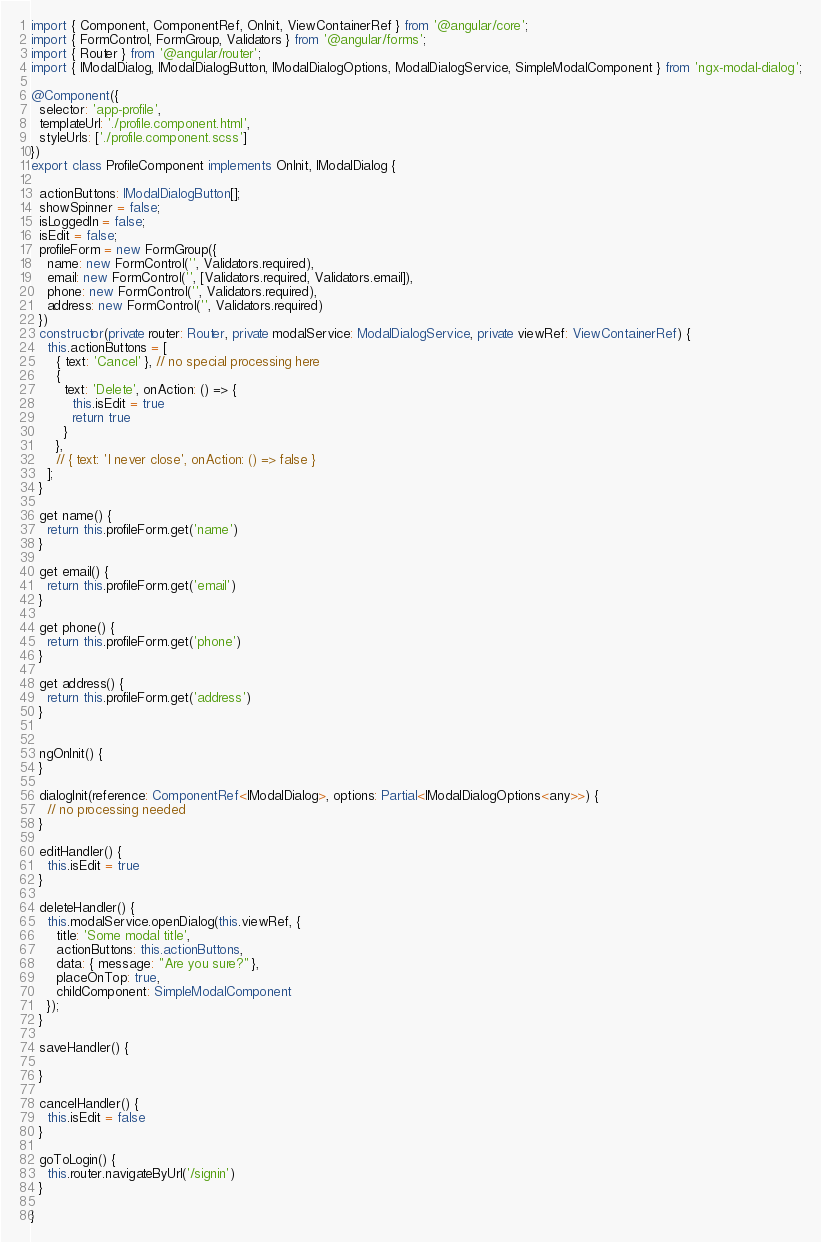Convert code to text. <code><loc_0><loc_0><loc_500><loc_500><_TypeScript_>import { Component, ComponentRef, OnInit, ViewContainerRef } from '@angular/core';
import { FormControl, FormGroup, Validators } from '@angular/forms';
import { Router } from '@angular/router';
import { IModalDialog, IModalDialogButton, IModalDialogOptions, ModalDialogService, SimpleModalComponent } from 'ngx-modal-dialog';

@Component({
  selector: 'app-profile',
  templateUrl: './profile.component.html',
  styleUrls: ['./profile.component.scss']
})
export class ProfileComponent implements OnInit, IModalDialog {

  actionButtons: IModalDialogButton[];
  showSpinner = false;
  isLoggedIn = false;
  isEdit = false;
  profileForm = new FormGroup({
    name: new FormControl('', Validators.required),
    email: new FormControl('', [Validators.required, Validators.email]),
    phone: new FormControl('', Validators.required),
    address: new FormControl('', Validators.required)
  })
  constructor(private router: Router, private modalService: ModalDialogService, private viewRef: ViewContainerRef) {
    this.actionButtons = [
      { text: 'Cancel' }, // no special processing here
      {
        text: 'Delete', onAction: () => {
          this.isEdit = true
          return true
        }
      },
      // { text: 'I never close', onAction: () => false }
    ];
  }

  get name() {
    return this.profileForm.get('name')
  }

  get email() {
    return this.profileForm.get('email')
  }

  get phone() {
    return this.profileForm.get('phone')
  }

  get address() {
    return this.profileForm.get('address')
  }


  ngOnInit() {
  }

  dialogInit(reference: ComponentRef<IModalDialog>, options: Partial<IModalDialogOptions<any>>) {
    // no processing needed
  }

  editHandler() {
    this.isEdit = true
  }

  deleteHandler() {
    this.modalService.openDialog(this.viewRef, {
      title: 'Some modal title',
      actionButtons: this.actionButtons,
      data: { message: "Are you sure?" },
      placeOnTop: true,
      childComponent: SimpleModalComponent
    });
  }

  saveHandler() {

  }

  cancelHandler() {
    this.isEdit = false
  }

  goToLogin() {
    this.router.navigateByUrl('/signin')
  }

}
</code> 